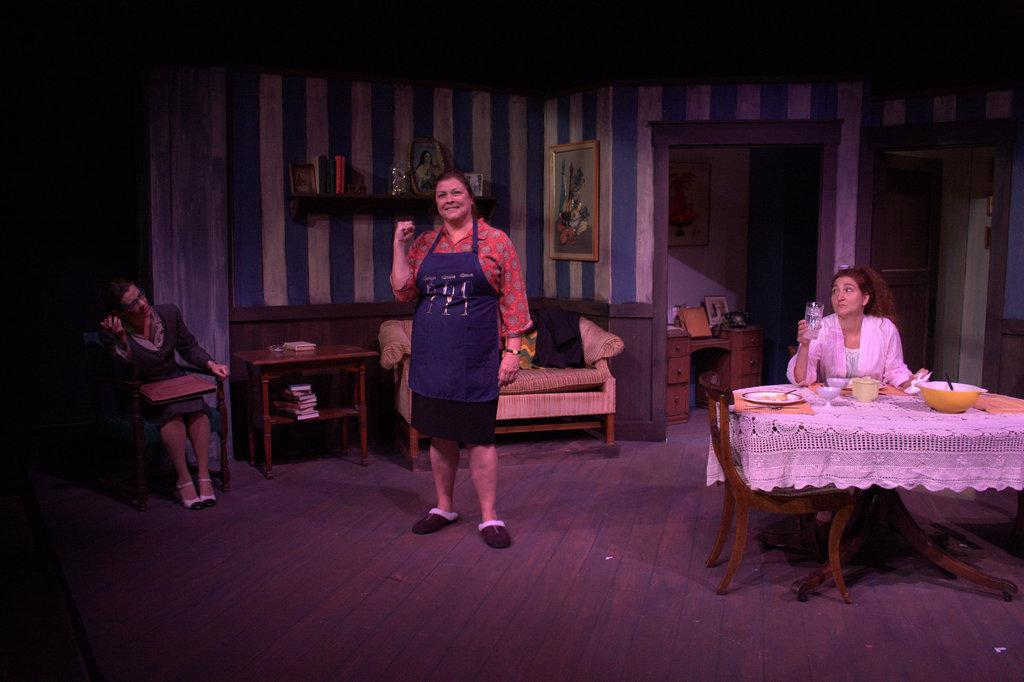What is the main subject of the image? There is a woman standing in the image. Can you describe the setting of the image? There is a chair, a table, a frame attached to the wall, and a couch in the image. Are there any other people in the image besides the woman standing? Yes, there is another woman in the background and another person sitting in a chair in the image. What else can be seen in the image? There are books in the image. What is the rate of lumber production in the image? There is no mention of lumber production in the image, so it is not possible to determine the rate. 